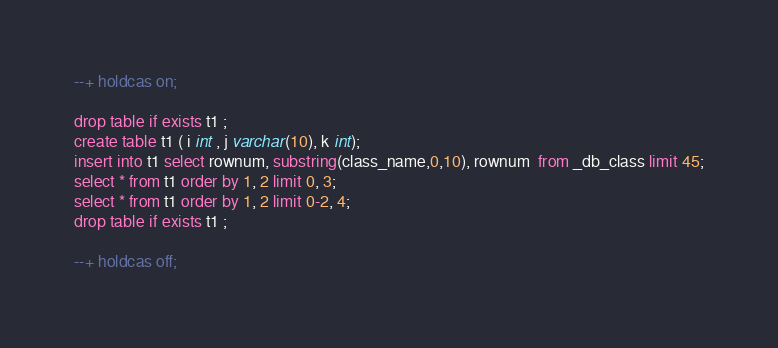Convert code to text. <code><loc_0><loc_0><loc_500><loc_500><_SQL_>--+ holdcas on;

drop table if exists t1 ;
create table t1 ( i int , j varchar(10), k int);
insert into t1 select rownum, substring(class_name,0,10), rownum  from _db_class limit 45;
select * from t1 order by 1, 2 limit 0, 3;     
select * from t1 order by 1, 2 limit 0-2, 4;
drop table if exists t1 ; 

--+ holdcas off;

</code> 